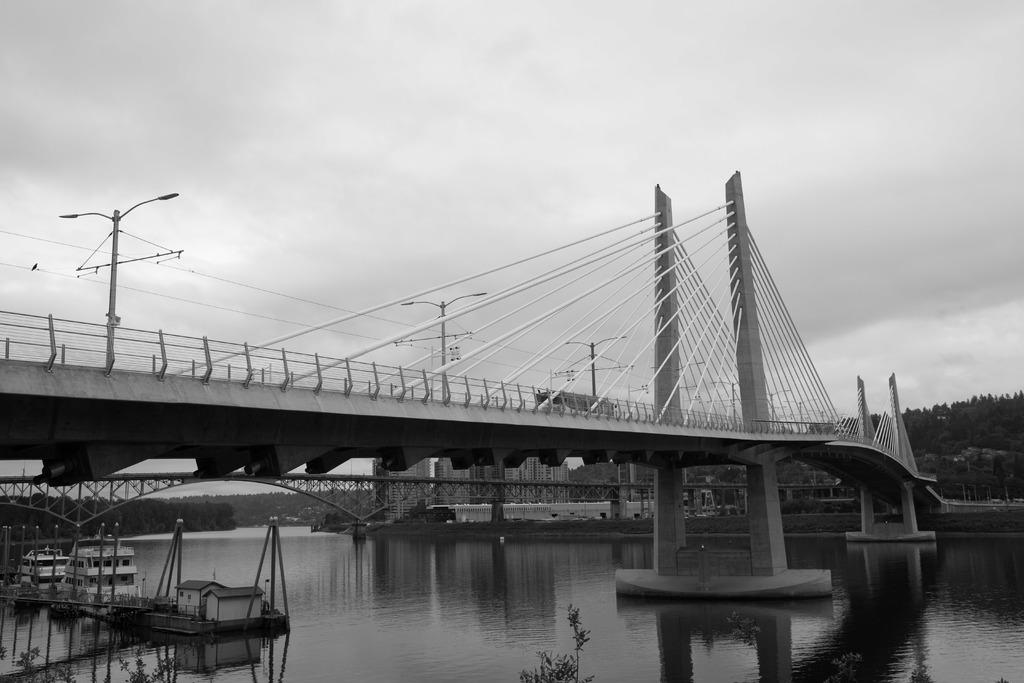What structure is the main subject of the image? There is a bridge in the image. What feature can be seen on the bridge? The bridge has cables attached to it. What is the bridge placed over? The bridge is placed over water. What can be seen in the background of the image? There are buildings, trees, and the sky visible in the background of the image. What type of book is being read by the spoon in the image? There is no spoon or book present in the image. What suggestion is being made by the trees in the background of the image? The trees in the background of the image are not making any suggestions; they are simply part of the scenery. 